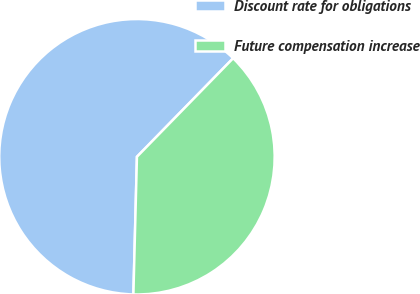<chart> <loc_0><loc_0><loc_500><loc_500><pie_chart><fcel>Discount rate for obligations<fcel>Future compensation increase<nl><fcel>61.9%<fcel>38.1%<nl></chart> 